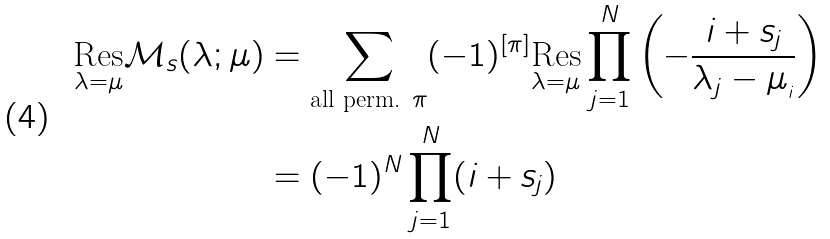Convert formula to latex. <formula><loc_0><loc_0><loc_500><loc_500>\underset { \lambda = \mu } { \text {Res} } \mathcal { M } _ { s } ( \lambda ; \mu ) & = \sum _ { \text {all perm. } \pi } ( - 1 ) ^ { [ \pi ] } \underset { \lambda = \mu } { \text {Res} } \prod _ { j = 1 } ^ { N } \left ( - \frac { i + s _ { j } } { \lambda _ { j } - \mu _ { _ { i } } } \right ) \\ & = ( - 1 ) ^ { N } \prod _ { j = 1 } ^ { N } ( i + s _ { j } )</formula> 